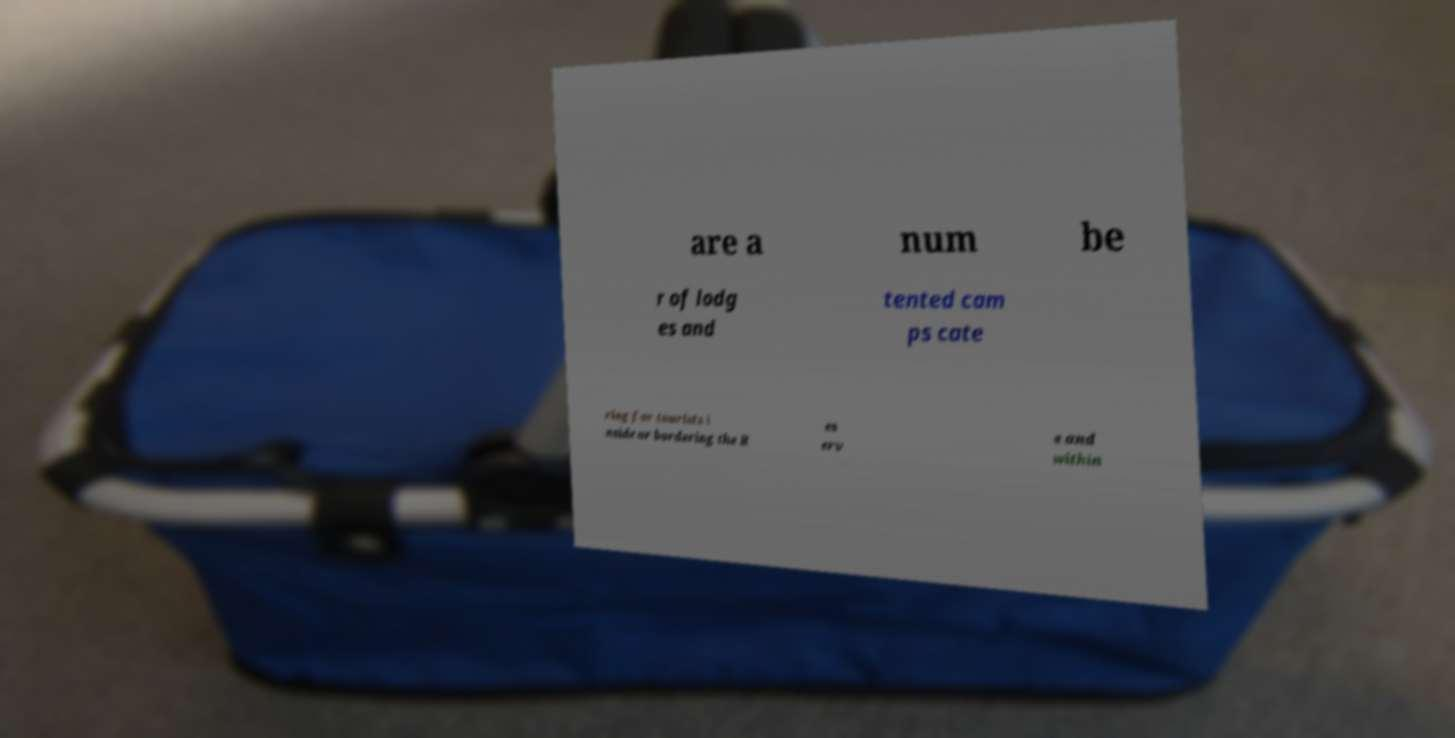Please identify and transcribe the text found in this image. are a num be r of lodg es and tented cam ps cate ring for tourists i nside or bordering the R es erv e and within 